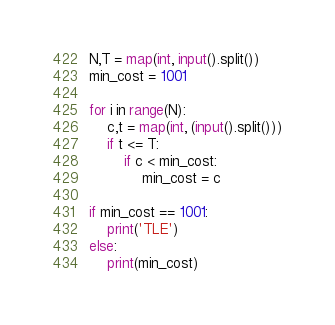Convert code to text. <code><loc_0><loc_0><loc_500><loc_500><_Python_>N,T = map(int, input().split())
min_cost = 1001

for i in range(N):
    c,t = map(int, (input().split()))
    if t <= T:
        if c < min_cost:
            min_cost = c

if min_cost == 1001:
    print('TLE')
else:
    print(min_cost)
</code> 